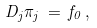Convert formula to latex. <formula><loc_0><loc_0><loc_500><loc_500>D _ { j } \pi _ { j } \, = \, f _ { 0 } \, ,</formula> 